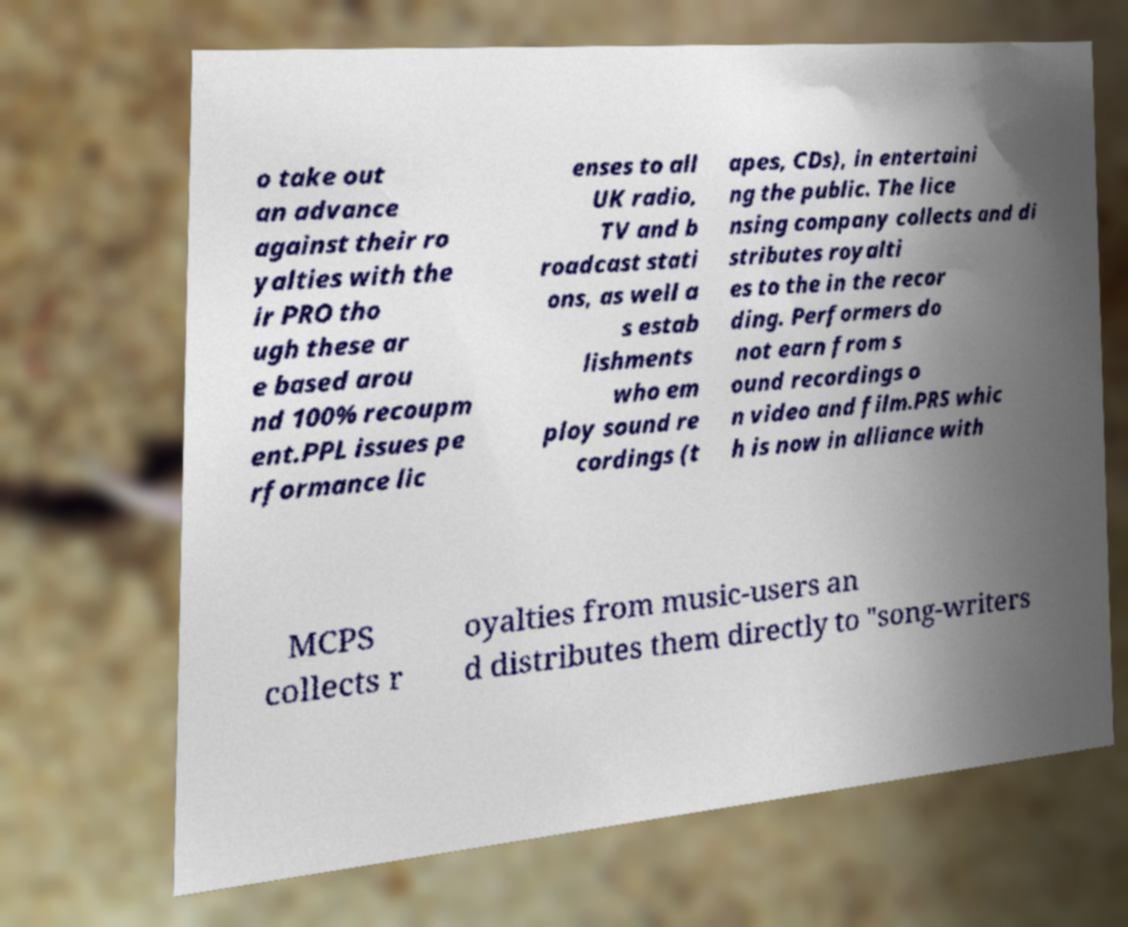Could you assist in decoding the text presented in this image and type it out clearly? o take out an advance against their ro yalties with the ir PRO tho ugh these ar e based arou nd 100% recoupm ent.PPL issues pe rformance lic enses to all UK radio, TV and b roadcast stati ons, as well a s estab lishments who em ploy sound re cordings (t apes, CDs), in entertaini ng the public. The lice nsing company collects and di stributes royalti es to the in the recor ding. Performers do not earn from s ound recordings o n video and film.PRS whic h is now in alliance with MCPS collects r oyalties from music-users an d distributes them directly to "song-writers 